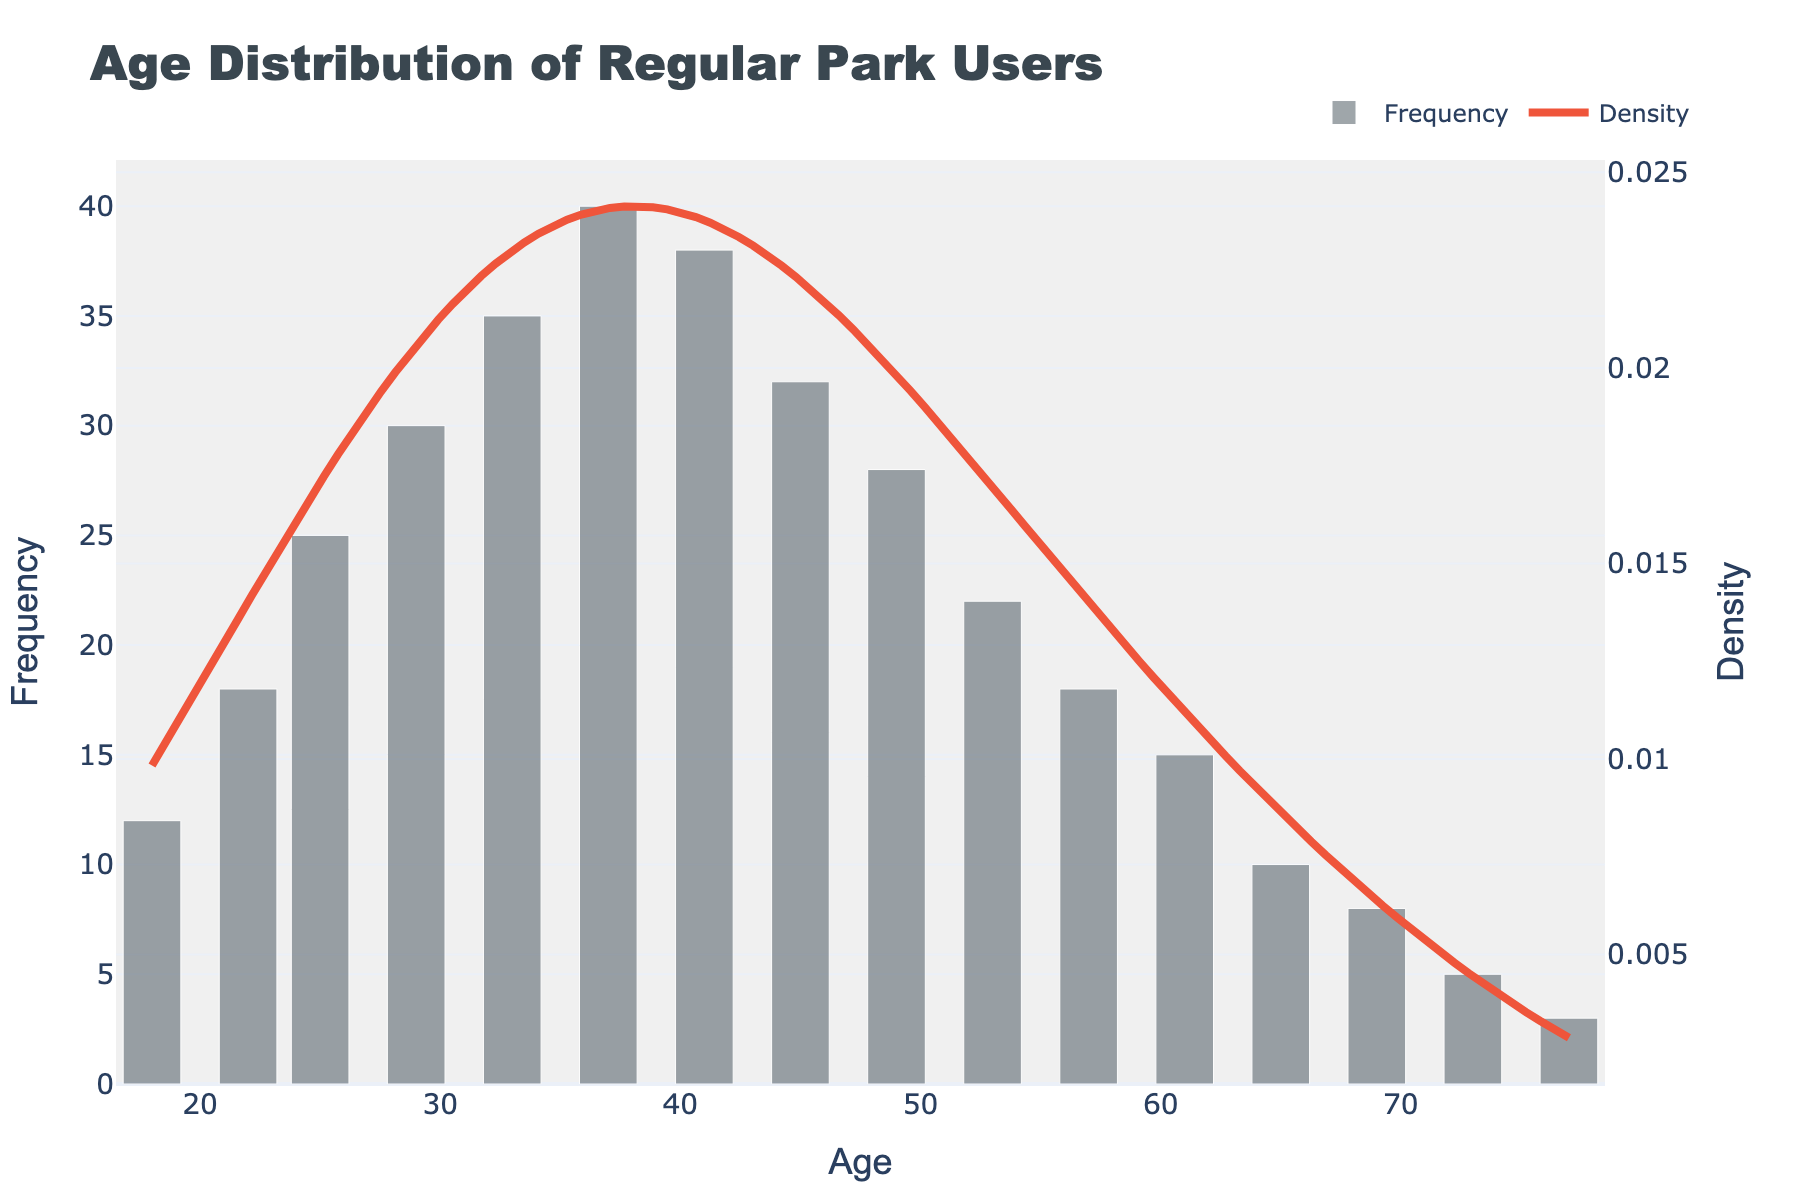What's the title of the figure? The title is usually displayed at the top of the figure, indicating what the plot is about. By looking at the top of the figure, you can find the title saying "Age Distribution of Regular Park Users".
Answer: Age Distribution of Regular Park Users What does the x-axis represent? The label on the x-axis indicates what variable is being measured. In this case, the x-axis label is "Age", representing the ages of park users.
Answer: Age What does the y-axis represent for the bar graph? The label on the primary y-axis (on the left side) specifies the metric being measured by the bars. Here, it is labeled "Frequency", indicating the number of park users within each age group.
Answer: Frequency What does the y-axis represent for the KDE curve? The label on the secondary y-axis (on the right side) specifies the metric for the KDE curve. It is labeled "Density", indicating the estimated density distribution of age among park users.
Answer: Density Which age group has the highest frequency of park users? By observing the height of the bars, we identify the tallest bar which signifies the age group with the highest frequency. The age group with the tallest bar is 37 years old.
Answer: 37 What is the approximate age range with the highest density according to the KDE curve? The peak of the KDE curve represents the highest density area. By looking at the KDE curve's highest point, we estimate the age range around 33 to 41 years where the density is highest.
Answer: 33-41 What is the total number of park users aged between 45 and 57? To find the total, sum the frequencies of the 45, 49, 53, and 57 age groups. The frequencies are 32, 28, 22, and 18 respectively. Thus, 32 + 28 + 22 + 18 = 100.
Answer: 100 How does the frequency of park users aged 22 compare to those aged 45? Comparing the height of the bars for age 22 (18 frequency) with age 45 (32 frequency), we see that age 45 has a higher frequency than age 22.
Answer: 45 > 22 What trend can be observed in the frequency of park users from age 18 to age 33? Observing the heights of the bars, we see an increasing trend in frequency from age 18 (12) to the peak at age 33 (35), showing that more park users belong to older age groups within this range.
Answer: Increasing What's the overall shape of the KDE curve? By observing the KDE curve, we notice a symmetrical shape with a peak around the age of 37, gradually decreasing towards both younger and older ages, indicating a normal-like distribution.
Answer: Symmetrical, normal-like distribution 